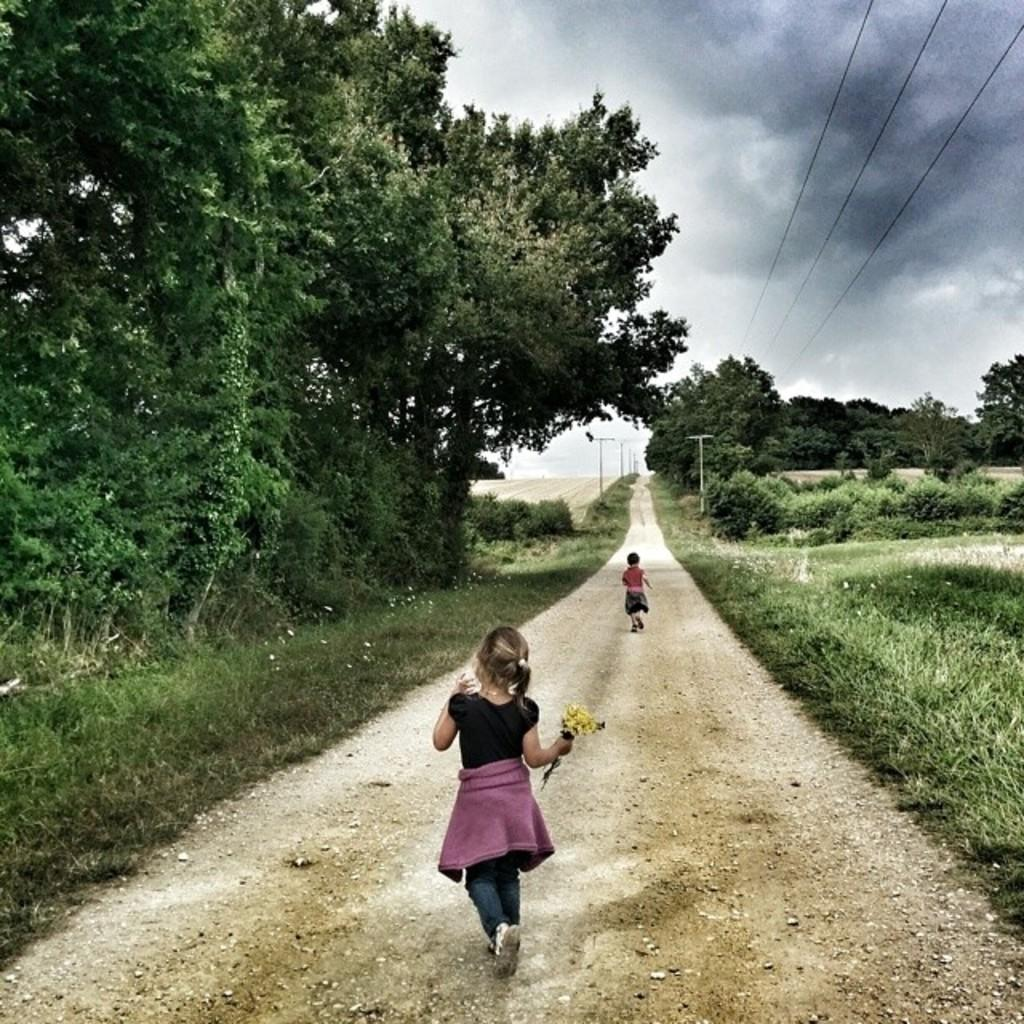How many kids can be seen in the image? There are two kids in the image. What are the kids doing in the image? The kids are walking on a path. What can be seen on either side of the path? There are plants and trees on either side of the path. What is visible in the sky in the image? The sky is visible in the image, and clouds are present. What type of fang can be seen in the image? There is no fang present in the image. How does the image portray the kids' temper? The image does not show the kids' temper; it only shows them walking on a path. 